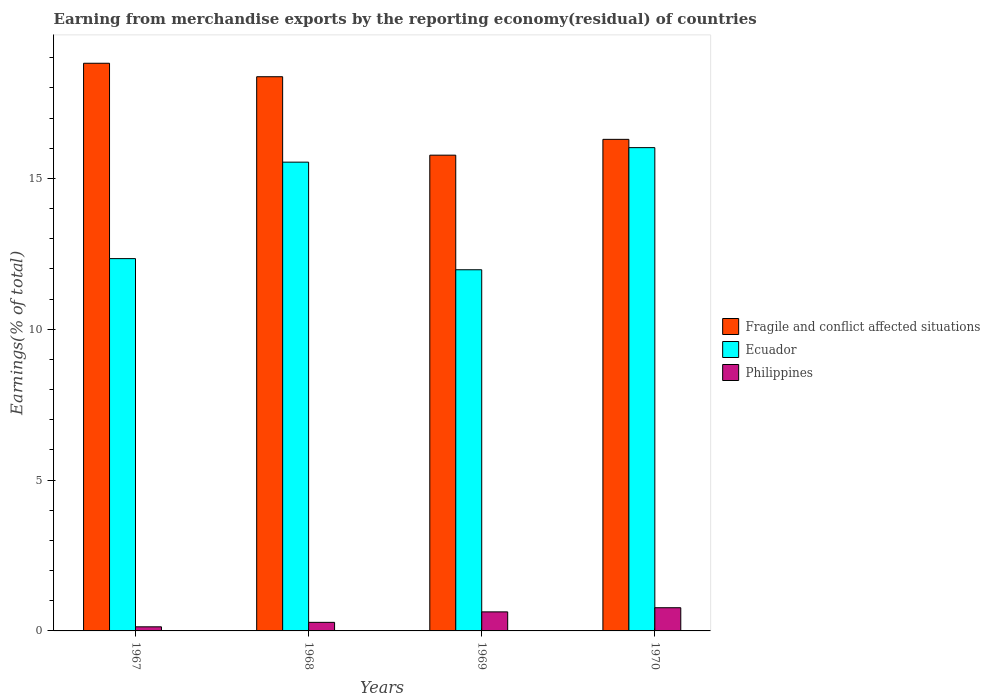Are the number of bars on each tick of the X-axis equal?
Keep it short and to the point. Yes. How many bars are there on the 3rd tick from the left?
Your answer should be compact. 3. How many bars are there on the 3rd tick from the right?
Your answer should be very brief. 3. What is the label of the 3rd group of bars from the left?
Ensure brevity in your answer.  1969. In how many cases, is the number of bars for a given year not equal to the number of legend labels?
Your response must be concise. 0. What is the percentage of amount earned from merchandise exports in Fragile and conflict affected situations in 1970?
Keep it short and to the point. 16.29. Across all years, what is the maximum percentage of amount earned from merchandise exports in Ecuador?
Provide a short and direct response. 16.02. Across all years, what is the minimum percentage of amount earned from merchandise exports in Philippines?
Offer a very short reply. 0.14. In which year was the percentage of amount earned from merchandise exports in Ecuador maximum?
Give a very brief answer. 1970. In which year was the percentage of amount earned from merchandise exports in Philippines minimum?
Ensure brevity in your answer.  1967. What is the total percentage of amount earned from merchandise exports in Ecuador in the graph?
Provide a short and direct response. 55.87. What is the difference between the percentage of amount earned from merchandise exports in Philippines in 1968 and that in 1970?
Make the answer very short. -0.49. What is the difference between the percentage of amount earned from merchandise exports in Ecuador in 1970 and the percentage of amount earned from merchandise exports in Philippines in 1967?
Ensure brevity in your answer.  15.88. What is the average percentage of amount earned from merchandise exports in Fragile and conflict affected situations per year?
Your answer should be compact. 17.31. In the year 1969, what is the difference between the percentage of amount earned from merchandise exports in Philippines and percentage of amount earned from merchandise exports in Fragile and conflict affected situations?
Ensure brevity in your answer.  -15.14. What is the ratio of the percentage of amount earned from merchandise exports in Fragile and conflict affected situations in 1969 to that in 1970?
Offer a very short reply. 0.97. Is the difference between the percentage of amount earned from merchandise exports in Philippines in 1968 and 1970 greater than the difference between the percentage of amount earned from merchandise exports in Fragile and conflict affected situations in 1968 and 1970?
Ensure brevity in your answer.  No. What is the difference between the highest and the second highest percentage of amount earned from merchandise exports in Fragile and conflict affected situations?
Your response must be concise. 0.45. What is the difference between the highest and the lowest percentage of amount earned from merchandise exports in Philippines?
Offer a terse response. 0.63. What does the 1st bar from the left in 1969 represents?
Give a very brief answer. Fragile and conflict affected situations. What does the 3rd bar from the right in 1969 represents?
Your answer should be compact. Fragile and conflict affected situations. Is it the case that in every year, the sum of the percentage of amount earned from merchandise exports in Fragile and conflict affected situations and percentage of amount earned from merchandise exports in Ecuador is greater than the percentage of amount earned from merchandise exports in Philippines?
Your answer should be compact. Yes. How many legend labels are there?
Offer a very short reply. 3. What is the title of the graph?
Offer a terse response. Earning from merchandise exports by the reporting economy(residual) of countries. What is the label or title of the Y-axis?
Keep it short and to the point. Earnings(% of total). What is the Earnings(% of total) in Fragile and conflict affected situations in 1967?
Your answer should be very brief. 18.82. What is the Earnings(% of total) of Ecuador in 1967?
Offer a very short reply. 12.34. What is the Earnings(% of total) in Philippines in 1967?
Give a very brief answer. 0.14. What is the Earnings(% of total) in Fragile and conflict affected situations in 1968?
Provide a succinct answer. 18.37. What is the Earnings(% of total) in Ecuador in 1968?
Your answer should be compact. 15.54. What is the Earnings(% of total) in Philippines in 1968?
Your response must be concise. 0.28. What is the Earnings(% of total) of Fragile and conflict affected situations in 1969?
Give a very brief answer. 15.77. What is the Earnings(% of total) of Ecuador in 1969?
Offer a very short reply. 11.97. What is the Earnings(% of total) of Philippines in 1969?
Keep it short and to the point. 0.63. What is the Earnings(% of total) of Fragile and conflict affected situations in 1970?
Your response must be concise. 16.29. What is the Earnings(% of total) of Ecuador in 1970?
Your answer should be compact. 16.02. What is the Earnings(% of total) in Philippines in 1970?
Keep it short and to the point. 0.77. Across all years, what is the maximum Earnings(% of total) of Fragile and conflict affected situations?
Make the answer very short. 18.82. Across all years, what is the maximum Earnings(% of total) of Ecuador?
Offer a terse response. 16.02. Across all years, what is the maximum Earnings(% of total) in Philippines?
Provide a succinct answer. 0.77. Across all years, what is the minimum Earnings(% of total) of Fragile and conflict affected situations?
Provide a succinct answer. 15.77. Across all years, what is the minimum Earnings(% of total) in Ecuador?
Offer a terse response. 11.97. Across all years, what is the minimum Earnings(% of total) in Philippines?
Provide a short and direct response. 0.14. What is the total Earnings(% of total) in Fragile and conflict affected situations in the graph?
Make the answer very short. 69.25. What is the total Earnings(% of total) in Ecuador in the graph?
Provide a succinct answer. 55.87. What is the total Earnings(% of total) of Philippines in the graph?
Offer a very short reply. 1.82. What is the difference between the Earnings(% of total) in Fragile and conflict affected situations in 1967 and that in 1968?
Keep it short and to the point. 0.45. What is the difference between the Earnings(% of total) in Ecuador in 1967 and that in 1968?
Offer a very short reply. -3.2. What is the difference between the Earnings(% of total) in Philippines in 1967 and that in 1968?
Make the answer very short. -0.15. What is the difference between the Earnings(% of total) of Fragile and conflict affected situations in 1967 and that in 1969?
Your answer should be very brief. 3.05. What is the difference between the Earnings(% of total) of Ecuador in 1967 and that in 1969?
Provide a short and direct response. 0.37. What is the difference between the Earnings(% of total) in Philippines in 1967 and that in 1969?
Make the answer very short. -0.5. What is the difference between the Earnings(% of total) of Fragile and conflict affected situations in 1967 and that in 1970?
Your response must be concise. 2.52. What is the difference between the Earnings(% of total) in Ecuador in 1967 and that in 1970?
Make the answer very short. -3.68. What is the difference between the Earnings(% of total) in Philippines in 1967 and that in 1970?
Offer a terse response. -0.63. What is the difference between the Earnings(% of total) in Fragile and conflict affected situations in 1968 and that in 1969?
Give a very brief answer. 2.6. What is the difference between the Earnings(% of total) in Ecuador in 1968 and that in 1969?
Keep it short and to the point. 3.57. What is the difference between the Earnings(% of total) of Philippines in 1968 and that in 1969?
Ensure brevity in your answer.  -0.35. What is the difference between the Earnings(% of total) of Fragile and conflict affected situations in 1968 and that in 1970?
Provide a short and direct response. 2.08. What is the difference between the Earnings(% of total) of Ecuador in 1968 and that in 1970?
Your response must be concise. -0.48. What is the difference between the Earnings(% of total) in Philippines in 1968 and that in 1970?
Offer a very short reply. -0.48. What is the difference between the Earnings(% of total) of Fragile and conflict affected situations in 1969 and that in 1970?
Make the answer very short. -0.52. What is the difference between the Earnings(% of total) in Ecuador in 1969 and that in 1970?
Keep it short and to the point. -4.05. What is the difference between the Earnings(% of total) of Philippines in 1969 and that in 1970?
Provide a short and direct response. -0.14. What is the difference between the Earnings(% of total) in Fragile and conflict affected situations in 1967 and the Earnings(% of total) in Ecuador in 1968?
Your answer should be compact. 3.28. What is the difference between the Earnings(% of total) in Fragile and conflict affected situations in 1967 and the Earnings(% of total) in Philippines in 1968?
Offer a very short reply. 18.53. What is the difference between the Earnings(% of total) of Ecuador in 1967 and the Earnings(% of total) of Philippines in 1968?
Provide a short and direct response. 12.06. What is the difference between the Earnings(% of total) in Fragile and conflict affected situations in 1967 and the Earnings(% of total) in Ecuador in 1969?
Give a very brief answer. 6.84. What is the difference between the Earnings(% of total) of Fragile and conflict affected situations in 1967 and the Earnings(% of total) of Philippines in 1969?
Offer a terse response. 18.19. What is the difference between the Earnings(% of total) in Ecuador in 1967 and the Earnings(% of total) in Philippines in 1969?
Provide a succinct answer. 11.71. What is the difference between the Earnings(% of total) in Fragile and conflict affected situations in 1967 and the Earnings(% of total) in Ecuador in 1970?
Your answer should be very brief. 2.8. What is the difference between the Earnings(% of total) in Fragile and conflict affected situations in 1967 and the Earnings(% of total) in Philippines in 1970?
Offer a terse response. 18.05. What is the difference between the Earnings(% of total) in Ecuador in 1967 and the Earnings(% of total) in Philippines in 1970?
Offer a terse response. 11.57. What is the difference between the Earnings(% of total) of Fragile and conflict affected situations in 1968 and the Earnings(% of total) of Ecuador in 1969?
Your response must be concise. 6.4. What is the difference between the Earnings(% of total) in Fragile and conflict affected situations in 1968 and the Earnings(% of total) in Philippines in 1969?
Provide a succinct answer. 17.74. What is the difference between the Earnings(% of total) in Ecuador in 1968 and the Earnings(% of total) in Philippines in 1969?
Provide a short and direct response. 14.91. What is the difference between the Earnings(% of total) in Fragile and conflict affected situations in 1968 and the Earnings(% of total) in Ecuador in 1970?
Make the answer very short. 2.35. What is the difference between the Earnings(% of total) in Fragile and conflict affected situations in 1968 and the Earnings(% of total) in Philippines in 1970?
Your answer should be compact. 17.6. What is the difference between the Earnings(% of total) of Ecuador in 1968 and the Earnings(% of total) of Philippines in 1970?
Your answer should be very brief. 14.77. What is the difference between the Earnings(% of total) of Fragile and conflict affected situations in 1969 and the Earnings(% of total) of Ecuador in 1970?
Offer a very short reply. -0.25. What is the difference between the Earnings(% of total) in Fragile and conflict affected situations in 1969 and the Earnings(% of total) in Philippines in 1970?
Make the answer very short. 15. What is the difference between the Earnings(% of total) of Ecuador in 1969 and the Earnings(% of total) of Philippines in 1970?
Ensure brevity in your answer.  11.2. What is the average Earnings(% of total) of Fragile and conflict affected situations per year?
Your answer should be compact. 17.31. What is the average Earnings(% of total) in Ecuador per year?
Give a very brief answer. 13.97. What is the average Earnings(% of total) in Philippines per year?
Offer a terse response. 0.46. In the year 1967, what is the difference between the Earnings(% of total) in Fragile and conflict affected situations and Earnings(% of total) in Ecuador?
Provide a succinct answer. 6.48. In the year 1967, what is the difference between the Earnings(% of total) of Fragile and conflict affected situations and Earnings(% of total) of Philippines?
Provide a short and direct response. 18.68. In the year 1967, what is the difference between the Earnings(% of total) in Ecuador and Earnings(% of total) in Philippines?
Make the answer very short. 12.21. In the year 1968, what is the difference between the Earnings(% of total) of Fragile and conflict affected situations and Earnings(% of total) of Ecuador?
Give a very brief answer. 2.83. In the year 1968, what is the difference between the Earnings(% of total) of Fragile and conflict affected situations and Earnings(% of total) of Philippines?
Provide a short and direct response. 18.09. In the year 1968, what is the difference between the Earnings(% of total) in Ecuador and Earnings(% of total) in Philippines?
Your answer should be very brief. 15.25. In the year 1969, what is the difference between the Earnings(% of total) in Fragile and conflict affected situations and Earnings(% of total) in Ecuador?
Keep it short and to the point. 3.8. In the year 1969, what is the difference between the Earnings(% of total) in Fragile and conflict affected situations and Earnings(% of total) in Philippines?
Make the answer very short. 15.14. In the year 1969, what is the difference between the Earnings(% of total) of Ecuador and Earnings(% of total) of Philippines?
Ensure brevity in your answer.  11.34. In the year 1970, what is the difference between the Earnings(% of total) in Fragile and conflict affected situations and Earnings(% of total) in Ecuador?
Provide a succinct answer. 0.27. In the year 1970, what is the difference between the Earnings(% of total) in Fragile and conflict affected situations and Earnings(% of total) in Philippines?
Offer a terse response. 15.53. In the year 1970, what is the difference between the Earnings(% of total) of Ecuador and Earnings(% of total) of Philippines?
Make the answer very short. 15.25. What is the ratio of the Earnings(% of total) of Fragile and conflict affected situations in 1967 to that in 1968?
Provide a short and direct response. 1.02. What is the ratio of the Earnings(% of total) in Ecuador in 1967 to that in 1968?
Ensure brevity in your answer.  0.79. What is the ratio of the Earnings(% of total) of Philippines in 1967 to that in 1968?
Your answer should be compact. 0.48. What is the ratio of the Earnings(% of total) in Fragile and conflict affected situations in 1967 to that in 1969?
Give a very brief answer. 1.19. What is the ratio of the Earnings(% of total) of Ecuador in 1967 to that in 1969?
Your answer should be very brief. 1.03. What is the ratio of the Earnings(% of total) of Philippines in 1967 to that in 1969?
Provide a succinct answer. 0.22. What is the ratio of the Earnings(% of total) of Fragile and conflict affected situations in 1967 to that in 1970?
Offer a terse response. 1.15. What is the ratio of the Earnings(% of total) in Ecuador in 1967 to that in 1970?
Your response must be concise. 0.77. What is the ratio of the Earnings(% of total) in Philippines in 1967 to that in 1970?
Your answer should be very brief. 0.18. What is the ratio of the Earnings(% of total) of Fragile and conflict affected situations in 1968 to that in 1969?
Provide a succinct answer. 1.16. What is the ratio of the Earnings(% of total) in Ecuador in 1968 to that in 1969?
Your answer should be very brief. 1.3. What is the ratio of the Earnings(% of total) in Philippines in 1968 to that in 1969?
Offer a very short reply. 0.45. What is the ratio of the Earnings(% of total) of Fragile and conflict affected situations in 1968 to that in 1970?
Give a very brief answer. 1.13. What is the ratio of the Earnings(% of total) of Philippines in 1968 to that in 1970?
Provide a succinct answer. 0.37. What is the ratio of the Earnings(% of total) in Fragile and conflict affected situations in 1969 to that in 1970?
Give a very brief answer. 0.97. What is the ratio of the Earnings(% of total) of Ecuador in 1969 to that in 1970?
Provide a short and direct response. 0.75. What is the ratio of the Earnings(% of total) of Philippines in 1969 to that in 1970?
Provide a short and direct response. 0.82. What is the difference between the highest and the second highest Earnings(% of total) of Fragile and conflict affected situations?
Provide a succinct answer. 0.45. What is the difference between the highest and the second highest Earnings(% of total) of Ecuador?
Make the answer very short. 0.48. What is the difference between the highest and the second highest Earnings(% of total) of Philippines?
Your answer should be very brief. 0.14. What is the difference between the highest and the lowest Earnings(% of total) of Fragile and conflict affected situations?
Your answer should be very brief. 3.05. What is the difference between the highest and the lowest Earnings(% of total) in Ecuador?
Ensure brevity in your answer.  4.05. What is the difference between the highest and the lowest Earnings(% of total) in Philippines?
Keep it short and to the point. 0.63. 